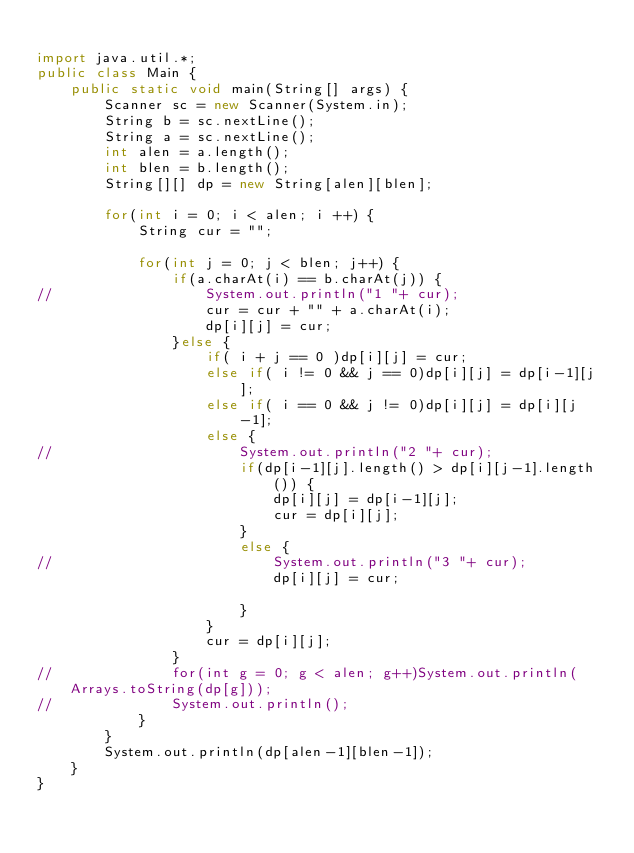<code> <loc_0><loc_0><loc_500><loc_500><_Java_>
import java.util.*;
public class Main {
	public static void main(String[] args) {
		Scanner sc = new Scanner(System.in);
		String b = sc.nextLine();
		String a = sc.nextLine();
		int alen = a.length();
		int blen = b.length();
		String[][] dp = new String[alen][blen];
		
		for(int i = 0; i < alen; i ++) {
			String cur = "";
			
			for(int j = 0; j < blen; j++) {
				if(a.charAt(i) == b.charAt(j)) {
//					System.out.println("1 "+ cur);
					cur = cur + "" + a.charAt(i);
					dp[i][j] = cur;
				}else {
					if( i + j == 0 )dp[i][j] = cur;
					else if( i != 0 && j == 0)dp[i][j] = dp[i-1][j];
					else if( i == 0 && j != 0)dp[i][j] = dp[i][j-1];
					else {
//						System.out.println("2 "+ cur);
						if(dp[i-1][j].length() > dp[i][j-1].length()) {
							dp[i][j] = dp[i-1][j];
							cur = dp[i][j];
						}
						else {
//							System.out.println("3 "+ cur);
							dp[i][j] = cur;

						}
					}
					cur = dp[i][j];
				}
//				for(int g = 0; g < alen; g++)System.out.println(Arrays.toString(dp[g]));
//				System.out.println();
			}
		}
		System.out.println(dp[alen-1][blen-1]);
	}
}
</code> 